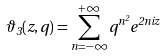Convert formula to latex. <formula><loc_0><loc_0><loc_500><loc_500>\vartheta _ { 3 } ( z , q ) = \sum _ { n = - \infty } ^ { + \infty } q ^ { n ^ { 2 } } e ^ { 2 n i z }</formula> 